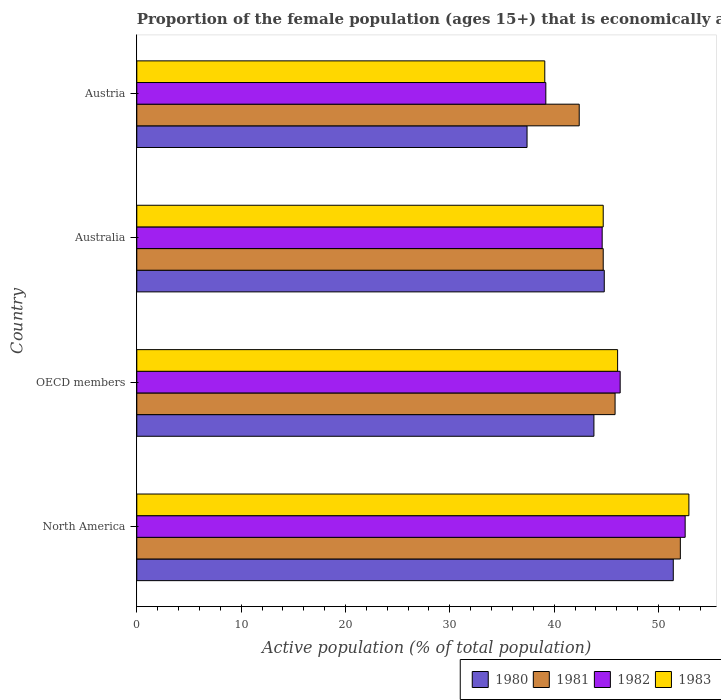How many different coloured bars are there?
Ensure brevity in your answer.  4. How many groups of bars are there?
Keep it short and to the point. 4. Are the number of bars on each tick of the Y-axis equal?
Your response must be concise. Yes. How many bars are there on the 3rd tick from the top?
Offer a very short reply. 4. In how many cases, is the number of bars for a given country not equal to the number of legend labels?
Keep it short and to the point. 0. What is the proportion of the female population that is economically active in 1980 in Australia?
Make the answer very short. 44.8. Across all countries, what is the maximum proportion of the female population that is economically active in 1983?
Provide a short and direct response. 52.91. Across all countries, what is the minimum proportion of the female population that is economically active in 1983?
Give a very brief answer. 39.1. In which country was the proportion of the female population that is economically active in 1982 minimum?
Offer a terse response. Austria. What is the total proportion of the female population that is economically active in 1982 in the graph?
Your response must be concise. 182.68. What is the difference between the proportion of the female population that is economically active in 1983 in Australia and that in OECD members?
Provide a short and direct response. -1.38. What is the difference between the proportion of the female population that is economically active in 1983 in OECD members and the proportion of the female population that is economically active in 1980 in Austria?
Make the answer very short. 8.68. What is the average proportion of the female population that is economically active in 1983 per country?
Keep it short and to the point. 45.7. What is the difference between the proportion of the female population that is economically active in 1982 and proportion of the female population that is economically active in 1983 in OECD members?
Offer a terse response. 0.25. What is the ratio of the proportion of the female population that is economically active in 1982 in Australia to that in North America?
Provide a succinct answer. 0.85. Is the difference between the proportion of the female population that is economically active in 1982 in Australia and Austria greater than the difference between the proportion of the female population that is economically active in 1983 in Australia and Austria?
Your response must be concise. No. What is the difference between the highest and the second highest proportion of the female population that is economically active in 1980?
Provide a short and direct response. 6.61. What is the difference between the highest and the lowest proportion of the female population that is economically active in 1983?
Make the answer very short. 13.81. Is it the case that in every country, the sum of the proportion of the female population that is economically active in 1981 and proportion of the female population that is economically active in 1982 is greater than the sum of proportion of the female population that is economically active in 1983 and proportion of the female population that is economically active in 1980?
Offer a terse response. No. What does the 4th bar from the top in North America represents?
Your answer should be very brief. 1980. Are all the bars in the graph horizontal?
Your answer should be very brief. Yes. How many countries are there in the graph?
Offer a very short reply. 4. Are the values on the major ticks of X-axis written in scientific E-notation?
Make the answer very short. No. Does the graph contain any zero values?
Your answer should be very brief. No. Does the graph contain grids?
Your response must be concise. No. Where does the legend appear in the graph?
Provide a short and direct response. Bottom right. What is the title of the graph?
Your answer should be compact. Proportion of the female population (ages 15+) that is economically active. What is the label or title of the X-axis?
Your answer should be compact. Active population (% of total population). What is the Active population (% of total population) of 1980 in North America?
Offer a very short reply. 51.41. What is the Active population (% of total population) in 1981 in North America?
Your response must be concise. 52.09. What is the Active population (% of total population) of 1982 in North America?
Your answer should be very brief. 52.55. What is the Active population (% of total population) of 1983 in North America?
Your answer should be very brief. 52.91. What is the Active population (% of total population) in 1980 in OECD members?
Offer a terse response. 43.81. What is the Active population (% of total population) in 1981 in OECD members?
Provide a succinct answer. 45.84. What is the Active population (% of total population) in 1982 in OECD members?
Provide a succinct answer. 46.32. What is the Active population (% of total population) in 1983 in OECD members?
Ensure brevity in your answer.  46.08. What is the Active population (% of total population) in 1980 in Australia?
Provide a short and direct response. 44.8. What is the Active population (% of total population) in 1981 in Australia?
Make the answer very short. 44.7. What is the Active population (% of total population) of 1982 in Australia?
Give a very brief answer. 44.6. What is the Active population (% of total population) of 1983 in Australia?
Offer a terse response. 44.7. What is the Active population (% of total population) in 1980 in Austria?
Give a very brief answer. 37.4. What is the Active population (% of total population) in 1981 in Austria?
Your answer should be very brief. 42.4. What is the Active population (% of total population) of 1982 in Austria?
Offer a terse response. 39.2. What is the Active population (% of total population) in 1983 in Austria?
Offer a very short reply. 39.1. Across all countries, what is the maximum Active population (% of total population) in 1980?
Your answer should be compact. 51.41. Across all countries, what is the maximum Active population (% of total population) in 1981?
Offer a terse response. 52.09. Across all countries, what is the maximum Active population (% of total population) of 1982?
Your answer should be very brief. 52.55. Across all countries, what is the maximum Active population (% of total population) of 1983?
Offer a terse response. 52.91. Across all countries, what is the minimum Active population (% of total population) of 1980?
Ensure brevity in your answer.  37.4. Across all countries, what is the minimum Active population (% of total population) of 1981?
Provide a short and direct response. 42.4. Across all countries, what is the minimum Active population (% of total population) in 1982?
Your response must be concise. 39.2. Across all countries, what is the minimum Active population (% of total population) of 1983?
Provide a short and direct response. 39.1. What is the total Active population (% of total population) in 1980 in the graph?
Keep it short and to the point. 177.42. What is the total Active population (% of total population) in 1981 in the graph?
Keep it short and to the point. 185.03. What is the total Active population (% of total population) in 1982 in the graph?
Your answer should be compact. 182.68. What is the total Active population (% of total population) of 1983 in the graph?
Keep it short and to the point. 182.79. What is the difference between the Active population (% of total population) in 1980 in North America and that in OECD members?
Provide a succinct answer. 7.61. What is the difference between the Active population (% of total population) of 1981 in North America and that in OECD members?
Your answer should be very brief. 6.25. What is the difference between the Active population (% of total population) in 1982 in North America and that in OECD members?
Your answer should be compact. 6.23. What is the difference between the Active population (% of total population) of 1983 in North America and that in OECD members?
Offer a very short reply. 6.83. What is the difference between the Active population (% of total population) of 1980 in North America and that in Australia?
Give a very brief answer. 6.61. What is the difference between the Active population (% of total population) in 1981 in North America and that in Australia?
Your answer should be compact. 7.39. What is the difference between the Active population (% of total population) of 1982 in North America and that in Australia?
Ensure brevity in your answer.  7.95. What is the difference between the Active population (% of total population) in 1983 in North America and that in Australia?
Your answer should be compact. 8.21. What is the difference between the Active population (% of total population) of 1980 in North America and that in Austria?
Your answer should be very brief. 14.01. What is the difference between the Active population (% of total population) in 1981 in North America and that in Austria?
Ensure brevity in your answer.  9.69. What is the difference between the Active population (% of total population) in 1982 in North America and that in Austria?
Your response must be concise. 13.35. What is the difference between the Active population (% of total population) in 1983 in North America and that in Austria?
Provide a succinct answer. 13.81. What is the difference between the Active population (% of total population) in 1980 in OECD members and that in Australia?
Offer a terse response. -0.99. What is the difference between the Active population (% of total population) of 1981 in OECD members and that in Australia?
Keep it short and to the point. 1.14. What is the difference between the Active population (% of total population) in 1982 in OECD members and that in Australia?
Your answer should be compact. 1.72. What is the difference between the Active population (% of total population) in 1983 in OECD members and that in Australia?
Provide a succinct answer. 1.38. What is the difference between the Active population (% of total population) in 1980 in OECD members and that in Austria?
Keep it short and to the point. 6.41. What is the difference between the Active population (% of total population) in 1981 in OECD members and that in Austria?
Make the answer very short. 3.44. What is the difference between the Active population (% of total population) in 1982 in OECD members and that in Austria?
Your answer should be very brief. 7.12. What is the difference between the Active population (% of total population) of 1983 in OECD members and that in Austria?
Your response must be concise. 6.98. What is the difference between the Active population (% of total population) in 1980 in Australia and that in Austria?
Give a very brief answer. 7.4. What is the difference between the Active population (% of total population) in 1981 in Australia and that in Austria?
Offer a very short reply. 2.3. What is the difference between the Active population (% of total population) in 1982 in Australia and that in Austria?
Make the answer very short. 5.4. What is the difference between the Active population (% of total population) in 1983 in Australia and that in Austria?
Your response must be concise. 5.6. What is the difference between the Active population (% of total population) of 1980 in North America and the Active population (% of total population) of 1981 in OECD members?
Offer a terse response. 5.58. What is the difference between the Active population (% of total population) of 1980 in North America and the Active population (% of total population) of 1982 in OECD members?
Offer a very short reply. 5.09. What is the difference between the Active population (% of total population) in 1980 in North America and the Active population (% of total population) in 1983 in OECD members?
Keep it short and to the point. 5.34. What is the difference between the Active population (% of total population) of 1981 in North America and the Active population (% of total population) of 1982 in OECD members?
Provide a short and direct response. 5.77. What is the difference between the Active population (% of total population) of 1981 in North America and the Active population (% of total population) of 1983 in OECD members?
Provide a succinct answer. 6.01. What is the difference between the Active population (% of total population) in 1982 in North America and the Active population (% of total population) in 1983 in OECD members?
Ensure brevity in your answer.  6.47. What is the difference between the Active population (% of total population) in 1980 in North America and the Active population (% of total population) in 1981 in Australia?
Keep it short and to the point. 6.71. What is the difference between the Active population (% of total population) in 1980 in North America and the Active population (% of total population) in 1982 in Australia?
Your response must be concise. 6.81. What is the difference between the Active population (% of total population) in 1980 in North America and the Active population (% of total population) in 1983 in Australia?
Your response must be concise. 6.71. What is the difference between the Active population (% of total population) of 1981 in North America and the Active population (% of total population) of 1982 in Australia?
Make the answer very short. 7.49. What is the difference between the Active population (% of total population) of 1981 in North America and the Active population (% of total population) of 1983 in Australia?
Provide a succinct answer. 7.39. What is the difference between the Active population (% of total population) in 1982 in North America and the Active population (% of total population) in 1983 in Australia?
Your answer should be compact. 7.85. What is the difference between the Active population (% of total population) of 1980 in North America and the Active population (% of total population) of 1981 in Austria?
Offer a very short reply. 9.01. What is the difference between the Active population (% of total population) of 1980 in North America and the Active population (% of total population) of 1982 in Austria?
Make the answer very short. 12.21. What is the difference between the Active population (% of total population) in 1980 in North America and the Active population (% of total population) in 1983 in Austria?
Offer a very short reply. 12.31. What is the difference between the Active population (% of total population) in 1981 in North America and the Active population (% of total population) in 1982 in Austria?
Keep it short and to the point. 12.89. What is the difference between the Active population (% of total population) of 1981 in North America and the Active population (% of total population) of 1983 in Austria?
Ensure brevity in your answer.  12.99. What is the difference between the Active population (% of total population) of 1982 in North America and the Active population (% of total population) of 1983 in Austria?
Your answer should be very brief. 13.45. What is the difference between the Active population (% of total population) in 1980 in OECD members and the Active population (% of total population) in 1981 in Australia?
Ensure brevity in your answer.  -0.89. What is the difference between the Active population (% of total population) of 1980 in OECD members and the Active population (% of total population) of 1982 in Australia?
Provide a short and direct response. -0.79. What is the difference between the Active population (% of total population) of 1980 in OECD members and the Active population (% of total population) of 1983 in Australia?
Provide a succinct answer. -0.89. What is the difference between the Active population (% of total population) of 1981 in OECD members and the Active population (% of total population) of 1982 in Australia?
Your response must be concise. 1.24. What is the difference between the Active population (% of total population) in 1981 in OECD members and the Active population (% of total population) in 1983 in Australia?
Keep it short and to the point. 1.14. What is the difference between the Active population (% of total population) in 1982 in OECD members and the Active population (% of total population) in 1983 in Australia?
Your answer should be very brief. 1.62. What is the difference between the Active population (% of total population) of 1980 in OECD members and the Active population (% of total population) of 1981 in Austria?
Offer a very short reply. 1.41. What is the difference between the Active population (% of total population) of 1980 in OECD members and the Active population (% of total population) of 1982 in Austria?
Your response must be concise. 4.61. What is the difference between the Active population (% of total population) of 1980 in OECD members and the Active population (% of total population) of 1983 in Austria?
Offer a terse response. 4.71. What is the difference between the Active population (% of total population) of 1981 in OECD members and the Active population (% of total population) of 1982 in Austria?
Keep it short and to the point. 6.64. What is the difference between the Active population (% of total population) of 1981 in OECD members and the Active population (% of total population) of 1983 in Austria?
Keep it short and to the point. 6.74. What is the difference between the Active population (% of total population) of 1982 in OECD members and the Active population (% of total population) of 1983 in Austria?
Ensure brevity in your answer.  7.22. What is the difference between the Active population (% of total population) in 1980 in Australia and the Active population (% of total population) in 1981 in Austria?
Provide a succinct answer. 2.4. What is the difference between the Active population (% of total population) in 1980 in Australia and the Active population (% of total population) in 1982 in Austria?
Provide a succinct answer. 5.6. What is the difference between the Active population (% of total population) of 1981 in Australia and the Active population (% of total population) of 1982 in Austria?
Ensure brevity in your answer.  5.5. What is the average Active population (% of total population) of 1980 per country?
Make the answer very short. 44.36. What is the average Active population (% of total population) in 1981 per country?
Offer a very short reply. 46.26. What is the average Active population (% of total population) of 1982 per country?
Your answer should be very brief. 45.67. What is the average Active population (% of total population) of 1983 per country?
Your response must be concise. 45.7. What is the difference between the Active population (% of total population) of 1980 and Active population (% of total population) of 1981 in North America?
Ensure brevity in your answer.  -0.68. What is the difference between the Active population (% of total population) in 1980 and Active population (% of total population) in 1982 in North America?
Give a very brief answer. -1.14. What is the difference between the Active population (% of total population) in 1980 and Active population (% of total population) in 1983 in North America?
Offer a terse response. -1.5. What is the difference between the Active population (% of total population) of 1981 and Active population (% of total population) of 1982 in North America?
Offer a very short reply. -0.46. What is the difference between the Active population (% of total population) of 1981 and Active population (% of total population) of 1983 in North America?
Your answer should be compact. -0.82. What is the difference between the Active population (% of total population) of 1982 and Active population (% of total population) of 1983 in North America?
Ensure brevity in your answer.  -0.36. What is the difference between the Active population (% of total population) in 1980 and Active population (% of total population) in 1981 in OECD members?
Make the answer very short. -2.03. What is the difference between the Active population (% of total population) of 1980 and Active population (% of total population) of 1982 in OECD members?
Give a very brief answer. -2.52. What is the difference between the Active population (% of total population) in 1980 and Active population (% of total population) in 1983 in OECD members?
Offer a terse response. -2.27. What is the difference between the Active population (% of total population) in 1981 and Active population (% of total population) in 1982 in OECD members?
Your answer should be very brief. -0.49. What is the difference between the Active population (% of total population) of 1981 and Active population (% of total population) of 1983 in OECD members?
Make the answer very short. -0.24. What is the difference between the Active population (% of total population) of 1982 and Active population (% of total population) of 1983 in OECD members?
Your answer should be very brief. 0.25. What is the difference between the Active population (% of total population) in 1980 and Active population (% of total population) in 1981 in Australia?
Give a very brief answer. 0.1. What is the difference between the Active population (% of total population) of 1980 and Active population (% of total population) of 1982 in Australia?
Provide a short and direct response. 0.2. What is the difference between the Active population (% of total population) in 1980 and Active population (% of total population) in 1983 in Australia?
Keep it short and to the point. 0.1. What is the difference between the Active population (% of total population) in 1981 and Active population (% of total population) in 1983 in Australia?
Your response must be concise. 0. What is the difference between the Active population (% of total population) of 1982 and Active population (% of total population) of 1983 in Australia?
Give a very brief answer. -0.1. What is the difference between the Active population (% of total population) in 1980 and Active population (% of total population) in 1981 in Austria?
Your response must be concise. -5. What is the difference between the Active population (% of total population) of 1980 and Active population (% of total population) of 1982 in Austria?
Give a very brief answer. -1.8. What is the difference between the Active population (% of total population) in 1981 and Active population (% of total population) in 1982 in Austria?
Offer a very short reply. 3.2. What is the difference between the Active population (% of total population) in 1981 and Active population (% of total population) in 1983 in Austria?
Make the answer very short. 3.3. What is the difference between the Active population (% of total population) of 1982 and Active population (% of total population) of 1983 in Austria?
Ensure brevity in your answer.  0.1. What is the ratio of the Active population (% of total population) of 1980 in North America to that in OECD members?
Provide a succinct answer. 1.17. What is the ratio of the Active population (% of total population) of 1981 in North America to that in OECD members?
Provide a short and direct response. 1.14. What is the ratio of the Active population (% of total population) of 1982 in North America to that in OECD members?
Provide a succinct answer. 1.13. What is the ratio of the Active population (% of total population) in 1983 in North America to that in OECD members?
Give a very brief answer. 1.15. What is the ratio of the Active population (% of total population) of 1980 in North America to that in Australia?
Provide a succinct answer. 1.15. What is the ratio of the Active population (% of total population) in 1981 in North America to that in Australia?
Your answer should be compact. 1.17. What is the ratio of the Active population (% of total population) of 1982 in North America to that in Australia?
Your answer should be very brief. 1.18. What is the ratio of the Active population (% of total population) of 1983 in North America to that in Australia?
Provide a short and direct response. 1.18. What is the ratio of the Active population (% of total population) in 1980 in North America to that in Austria?
Offer a terse response. 1.37. What is the ratio of the Active population (% of total population) in 1981 in North America to that in Austria?
Your answer should be compact. 1.23. What is the ratio of the Active population (% of total population) in 1982 in North America to that in Austria?
Offer a very short reply. 1.34. What is the ratio of the Active population (% of total population) in 1983 in North America to that in Austria?
Your answer should be very brief. 1.35. What is the ratio of the Active population (% of total population) in 1980 in OECD members to that in Australia?
Give a very brief answer. 0.98. What is the ratio of the Active population (% of total population) of 1981 in OECD members to that in Australia?
Offer a very short reply. 1.03. What is the ratio of the Active population (% of total population) in 1982 in OECD members to that in Australia?
Your response must be concise. 1.04. What is the ratio of the Active population (% of total population) of 1983 in OECD members to that in Australia?
Provide a succinct answer. 1.03. What is the ratio of the Active population (% of total population) of 1980 in OECD members to that in Austria?
Your response must be concise. 1.17. What is the ratio of the Active population (% of total population) in 1981 in OECD members to that in Austria?
Your response must be concise. 1.08. What is the ratio of the Active population (% of total population) in 1982 in OECD members to that in Austria?
Ensure brevity in your answer.  1.18. What is the ratio of the Active population (% of total population) in 1983 in OECD members to that in Austria?
Offer a terse response. 1.18. What is the ratio of the Active population (% of total population) in 1980 in Australia to that in Austria?
Your answer should be very brief. 1.2. What is the ratio of the Active population (% of total population) in 1981 in Australia to that in Austria?
Offer a very short reply. 1.05. What is the ratio of the Active population (% of total population) in 1982 in Australia to that in Austria?
Make the answer very short. 1.14. What is the ratio of the Active population (% of total population) in 1983 in Australia to that in Austria?
Provide a short and direct response. 1.14. What is the difference between the highest and the second highest Active population (% of total population) of 1980?
Provide a short and direct response. 6.61. What is the difference between the highest and the second highest Active population (% of total population) in 1981?
Your response must be concise. 6.25. What is the difference between the highest and the second highest Active population (% of total population) in 1982?
Your answer should be very brief. 6.23. What is the difference between the highest and the second highest Active population (% of total population) of 1983?
Ensure brevity in your answer.  6.83. What is the difference between the highest and the lowest Active population (% of total population) in 1980?
Ensure brevity in your answer.  14.01. What is the difference between the highest and the lowest Active population (% of total population) of 1981?
Provide a short and direct response. 9.69. What is the difference between the highest and the lowest Active population (% of total population) in 1982?
Offer a very short reply. 13.35. What is the difference between the highest and the lowest Active population (% of total population) in 1983?
Your answer should be compact. 13.81. 